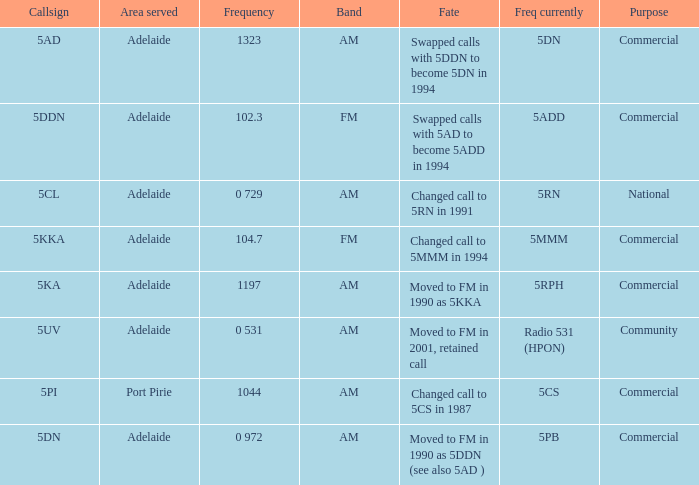What is the current freq for Frequency of 104.7? 5MMM. 